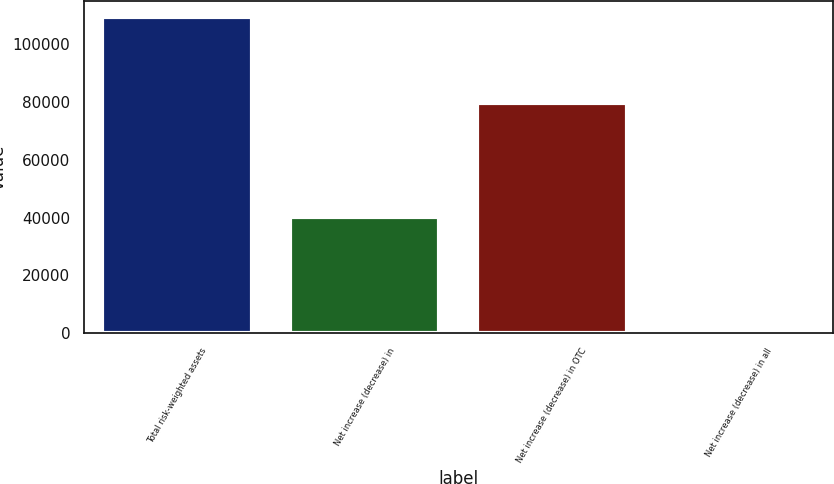Convert chart to OTSL. <chart><loc_0><loc_0><loc_500><loc_500><bar_chart><fcel>Total risk-weighted assets<fcel>Net increase (decrease) in<fcel>Net increase (decrease) in OTC<fcel>Net increase (decrease) in all<nl><fcel>109462<fcel>40089<fcel>79731<fcel>447<nl></chart> 